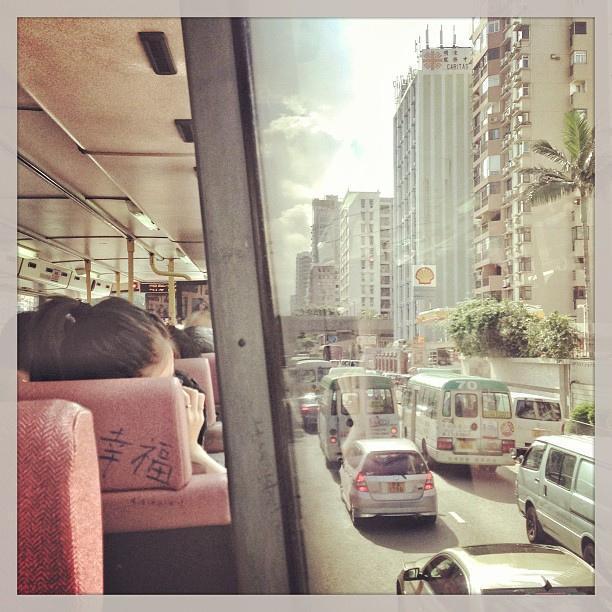How many cars are in the photo?
Give a very brief answer. 4. How many buses can you see?
Give a very brief answer. 2. 